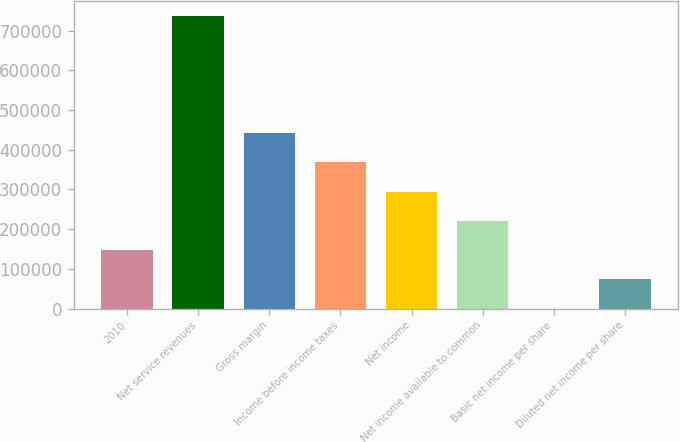Convert chart. <chart><loc_0><loc_0><loc_500><loc_500><bar_chart><fcel>2010<fcel>Net service revenues<fcel>Gross margin<fcel>Income before income taxes<fcel>Net income<fcel>Net income available to common<fcel>Basic net income per share<fcel>Diluted net income per share<nl><fcel>147435<fcel>737173<fcel>442304<fcel>368587<fcel>294869<fcel>221152<fcel>0.05<fcel>73717.4<nl></chart> 